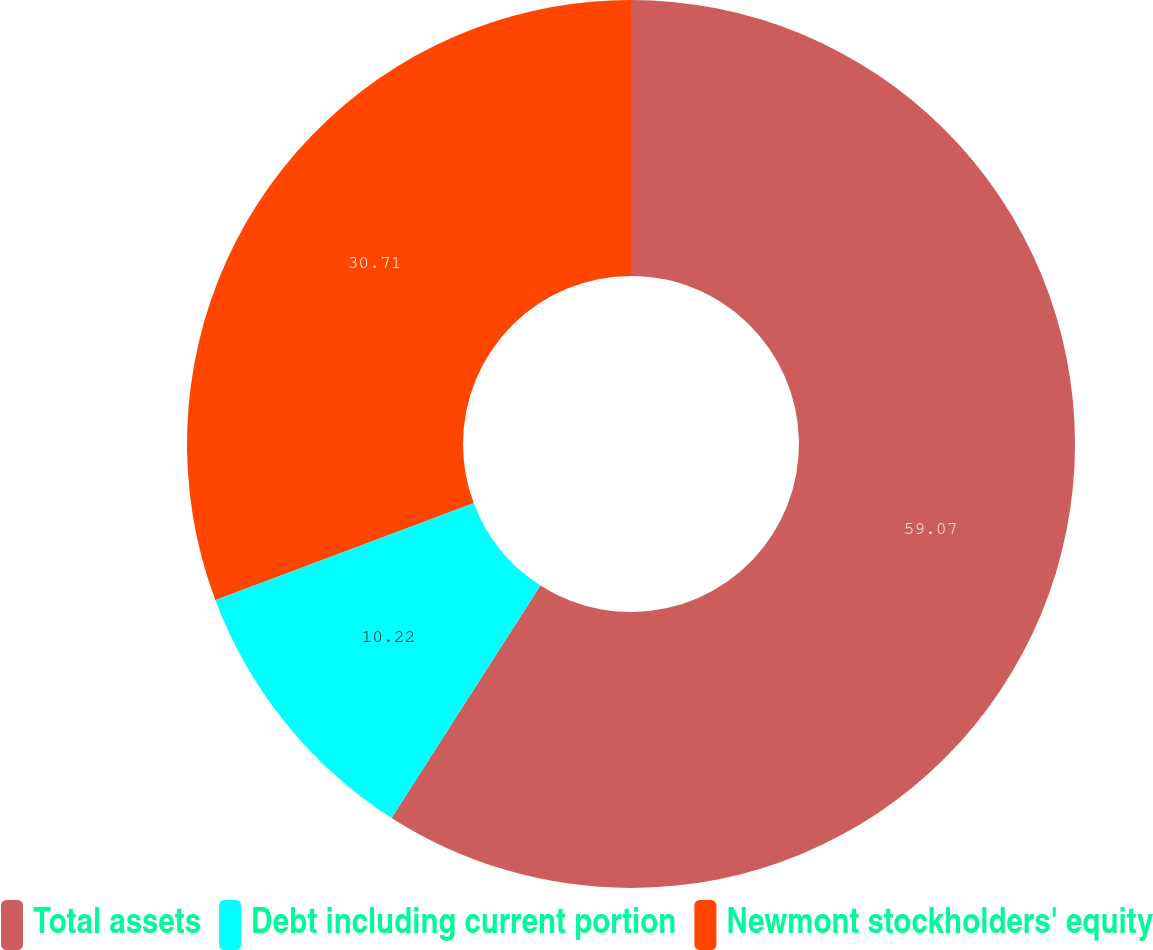Convert chart to OTSL. <chart><loc_0><loc_0><loc_500><loc_500><pie_chart><fcel>Total assets<fcel>Debt including current portion<fcel>Newmont stockholders' equity<nl><fcel>59.06%<fcel>10.22%<fcel>30.71%<nl></chart> 